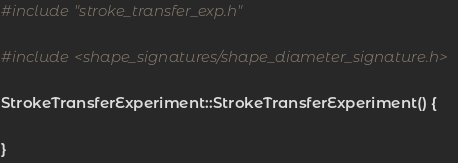<code> <loc_0><loc_0><loc_500><loc_500><_C++_>#include "stroke_transfer_exp.h"

#include <shape_signatures/shape_diameter_signature.h>

StrokeTransferExperiment::StrokeTransferExperiment() {

}
</code> 